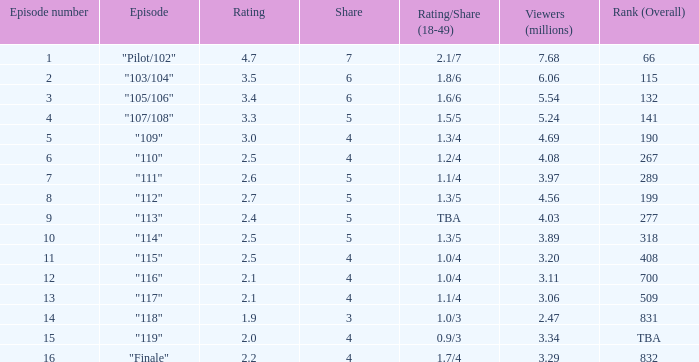What is the score that had a proportion less than 4, and 0.0. 